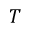Convert formula to latex. <formula><loc_0><loc_0><loc_500><loc_500>T</formula> 